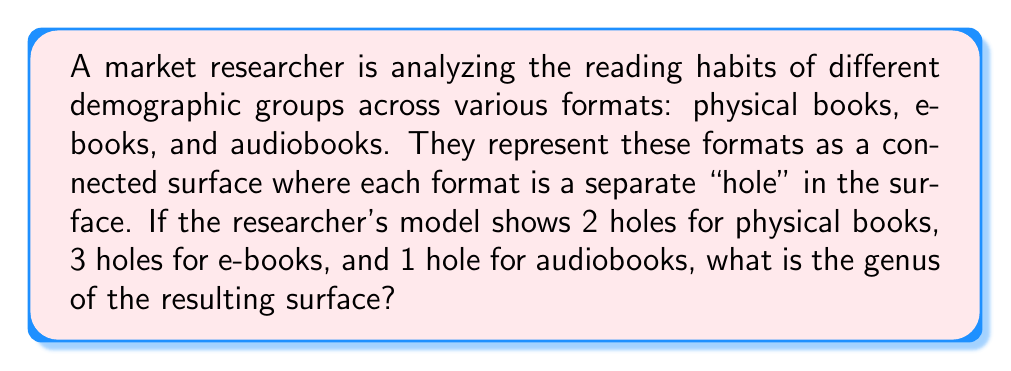Show me your answer to this math problem. To solve this problem, we need to understand the concept of genus in topology and how it relates to the given scenario.

1. In topology, the genus of a surface is the number of "holes" or "handles" in the surface.

2. For a connected surface, the genus is calculated by counting the total number of holes.

3. In this case, we have:
   - Physical books: 2 holes
   - E-books: 3 holes
   - Audiobooks: 1 hole

4. To find the genus, we simply sum up all the holes:

   $$g = 2 + 3 + 1 = 6$$

   Where $g$ represents the genus of the surface.

5. This surface can be visualized as a sphere with 6 handles, each handle representing a "hole" in the surface.

[asy]
import three;

size(200);
currentprojection=perspective(6,3,2);

// Draw the main sphere
draw(surface(sphere((0,0,0),1)),paleblue+opacity(0.5));

// Draw 6 handles
for(int i=0; i<6; ++i) {
  real angle = 2pi*i/6;
  triple center = (cos(angle),sin(angle),0);
  draw(surface(shift(center)*scale3(0.3)*rotate(90,(1,0,0))*circle((0,0,0),1)),red+opacity(0.7));
}
[/asy]

This topological representation allows the market researcher to visualize and analyze the relationship between different reading formats in a unified structure.
Answer: The genus of the surface representing different reading formats is 6. 